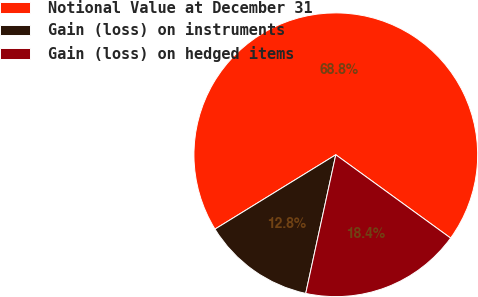Convert chart to OTSL. <chart><loc_0><loc_0><loc_500><loc_500><pie_chart><fcel>Notional Value at December 31<fcel>Gain (loss) on instruments<fcel>Gain (loss) on hedged items<nl><fcel>68.77%<fcel>12.82%<fcel>18.41%<nl></chart> 